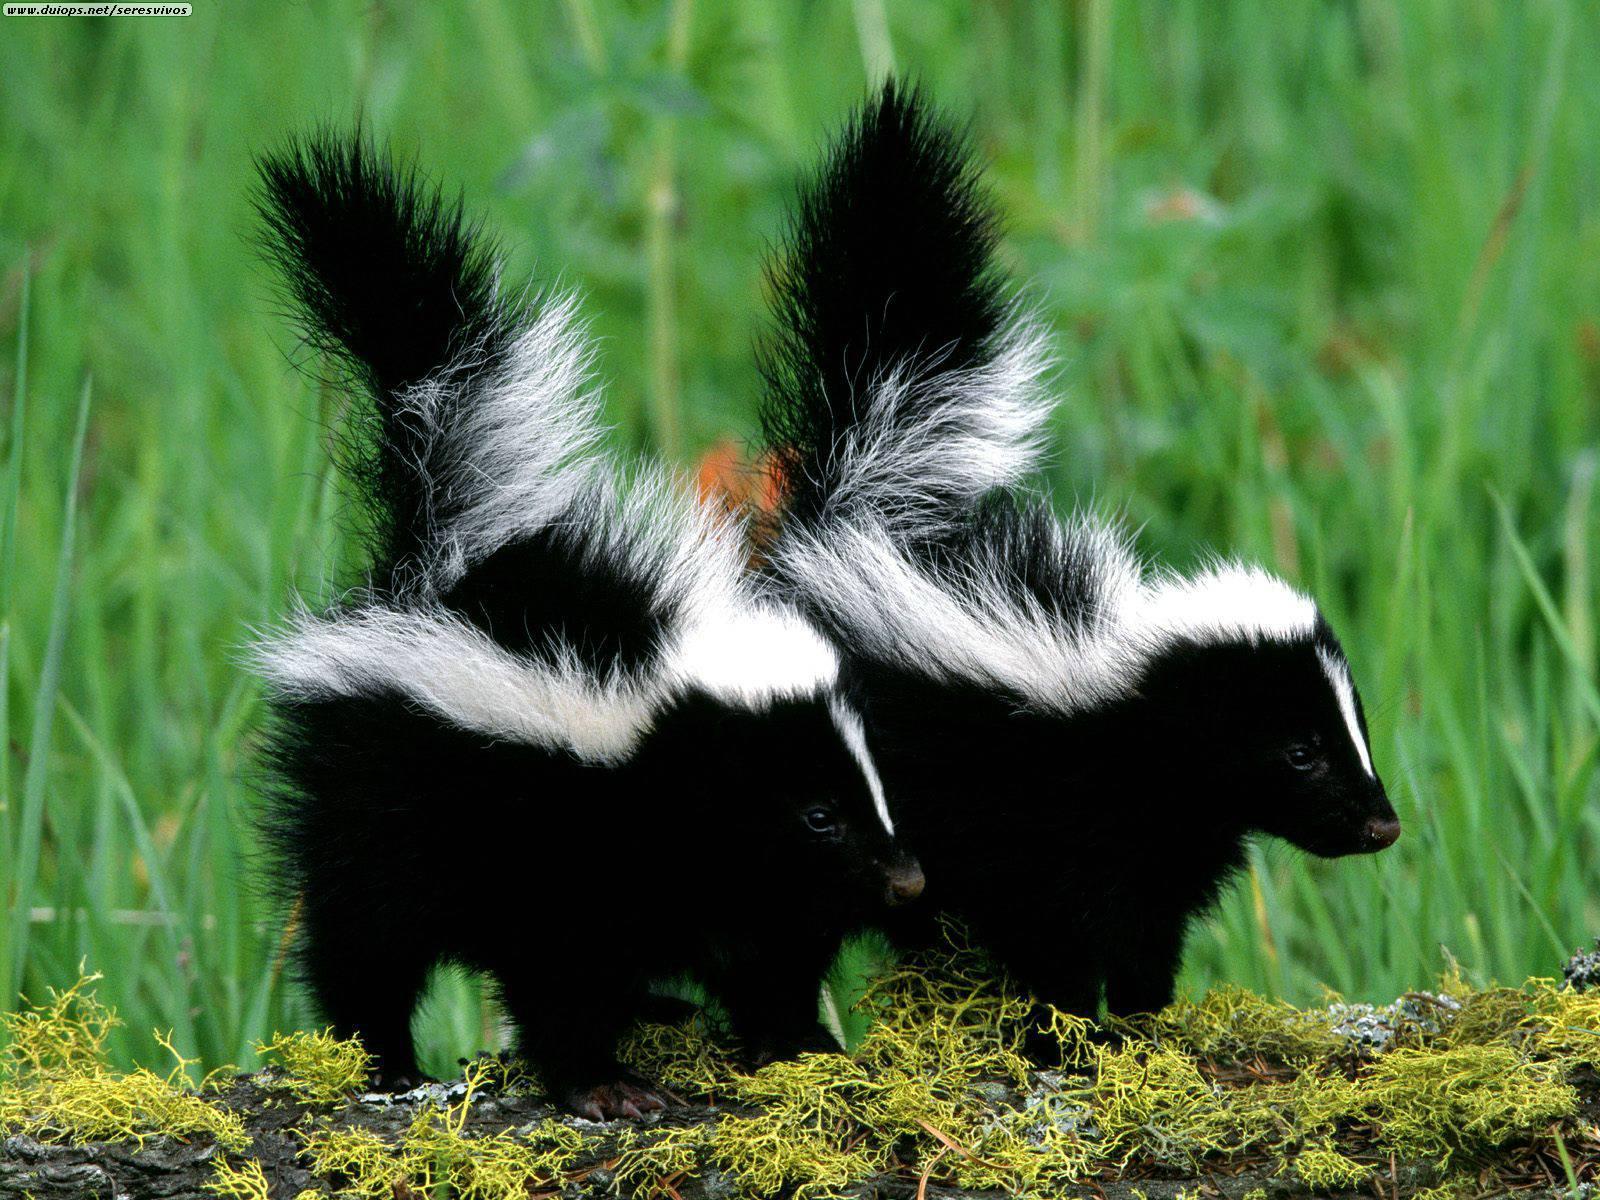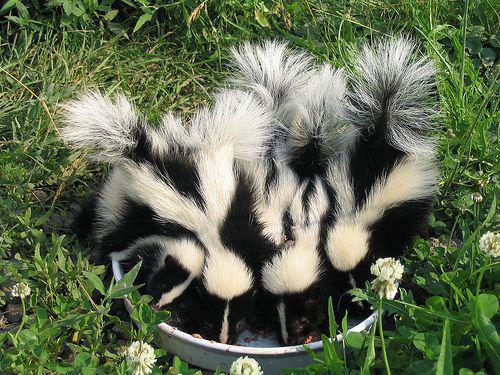The first image is the image on the left, the second image is the image on the right. For the images displayed, is the sentence "There are six skunks pictured." factually correct? Answer yes or no. Yes. 